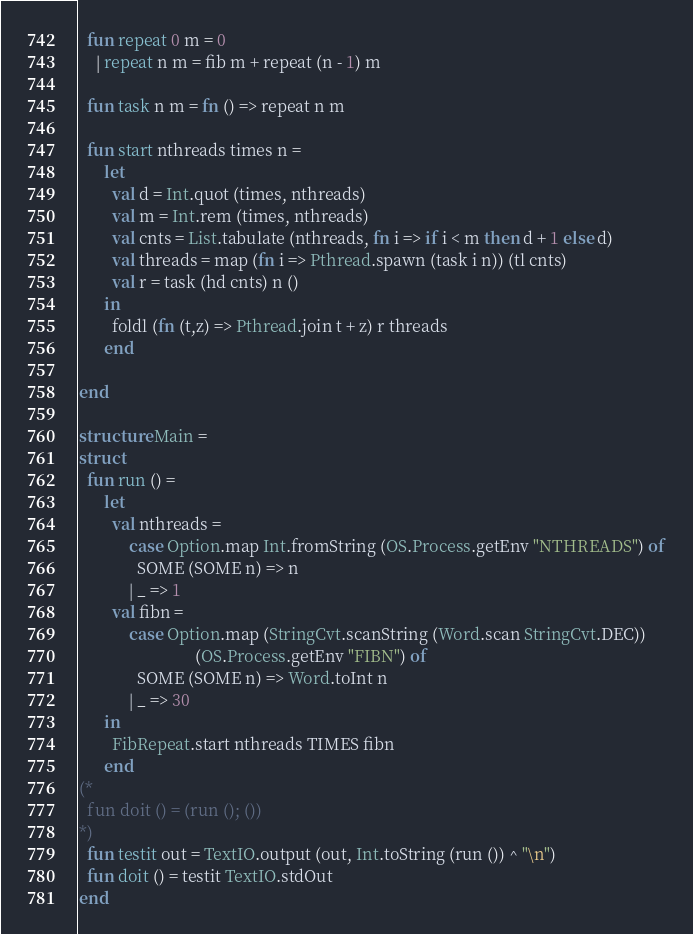<code> <loc_0><loc_0><loc_500><loc_500><_SML_>
  fun repeat 0 m = 0
    | repeat n m = fib m + repeat (n - 1) m

  fun task n m = fn () => repeat n m

  fun start nthreads times n =
      let
        val d = Int.quot (times, nthreads)
        val m = Int.rem (times, nthreads)
        val cnts = List.tabulate (nthreads, fn i => if i < m then d + 1 else d)
        val threads = map (fn i => Pthread.spawn (task i n)) (tl cnts)
        val r = task (hd cnts) n ()
      in
        foldl (fn (t,z) => Pthread.join t + z) r threads
      end

end

structure Main =
struct
  fun run () =
      let
        val nthreads =
            case Option.map Int.fromString (OS.Process.getEnv "NTHREADS") of
              SOME (SOME n) => n
            | _ => 1
        val fibn =
            case Option.map (StringCvt.scanString (Word.scan StringCvt.DEC))
                            (OS.Process.getEnv "FIBN") of
              SOME (SOME n) => Word.toInt n
            | _ => 30
      in
        FibRepeat.start nthreads TIMES fibn
      end
(*
  fun doit () = (run (); ())
*)
  fun testit out = TextIO.output (out, Int.toString (run ()) ^ "\n")
  fun doit () = testit TextIO.stdOut
end
</code> 